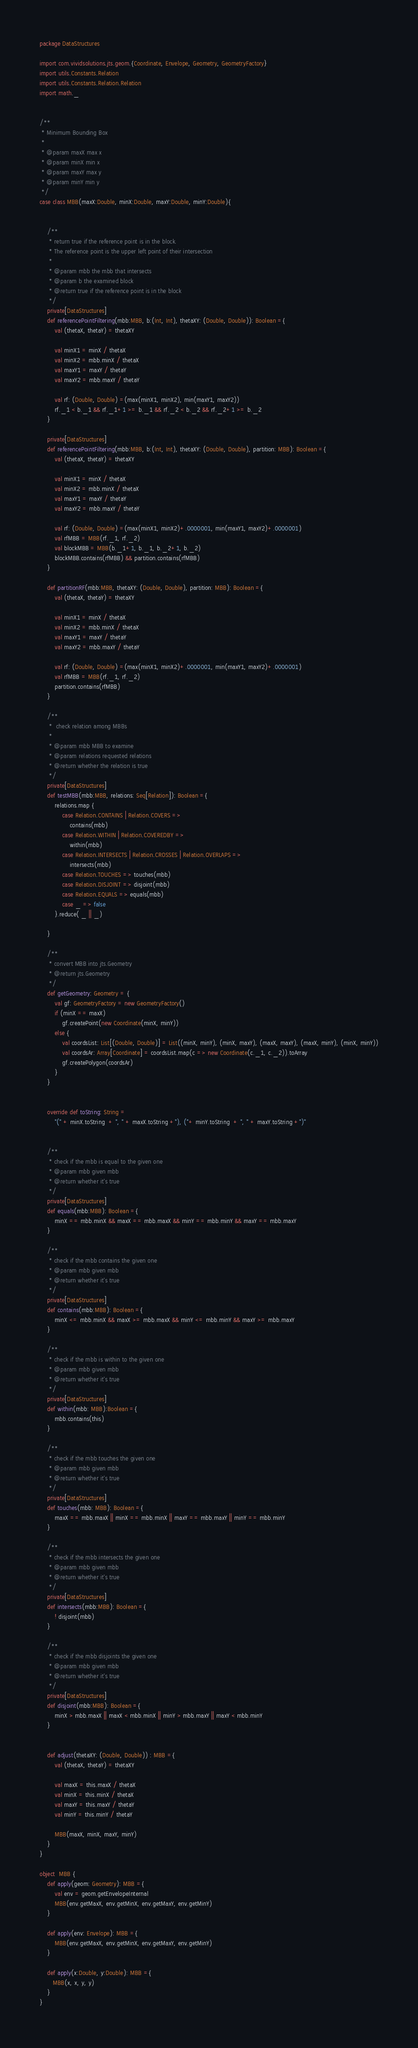Convert code to text. <code><loc_0><loc_0><loc_500><loc_500><_Scala_>package DataStructures

import com.vividsolutions.jts.geom.{Coordinate, Envelope, Geometry, GeometryFactory}
import utils.Constants.Relation
import utils.Constants.Relation.Relation
import math._


/**
 * Minimum Bounding Box
 *
 * @param maxX max x
 * @param minX min x
 * @param maxY max y
 * @param minY min y
 */
case class MBB(maxX:Double, minX:Double, maxY:Double, minY:Double){


    /**
     * return true if the reference point is in the block.
     * The reference point is the upper left point of their intersection
     *
     * @param mbb the mbb that intersects
     * @param b the examined block
     * @return true if the reference point is in the block
     */
    private[DataStructures]
    def referencePointFiltering(mbb:MBB, b:(Int, Int), thetaXY: (Double, Double)): Boolean ={
        val (thetaX, thetaY) = thetaXY

        val minX1 = minX / thetaX
        val minX2 = mbb.minX / thetaX
        val maxY1 = maxY / thetaY
        val maxY2 = mbb.maxY / thetaY

        val rf: (Double, Double) =(max(minX1, minX2), min(maxY1, maxY2))
        rf._1 < b._1 && rf._1+1 >= b._1 && rf._2 < b._2 && rf._2+1 >= b._2
    }

    private[DataStructures]
    def referencePointFiltering(mbb:MBB, b:(Int, Int), thetaXY: (Double, Double), partition: MBB): Boolean ={
        val (thetaX, thetaY) = thetaXY

        val minX1 = minX / thetaX
        val minX2 = mbb.minX / thetaX
        val maxY1 = maxY / thetaY
        val maxY2 = mbb.maxY / thetaY

        val rf: (Double, Double) =(max(minX1, minX2)+.0000001, min(maxY1, maxY2)+.0000001)
        val rfMBB = MBB(rf._1, rf._2)
        val blockMBB = MBB(b._1+1, b._1, b._2+1, b._2)
        blockMBB.contains(rfMBB) && partition.contains(rfMBB)
    }

    def partitionRF(mbb:MBB, thetaXY: (Double, Double), partition: MBB): Boolean ={
        val (thetaX, thetaY) = thetaXY

        val minX1 = minX / thetaX
        val minX2 = mbb.minX / thetaX
        val maxY1 = maxY / thetaY
        val maxY2 = mbb.maxY / thetaY

        val rf: (Double, Double) =(max(minX1, minX2)+.0000001, min(maxY1, maxY2)+.0000001)
        val rfMBB = MBB(rf._1, rf._2)
        partition.contains(rfMBB)
    }

    /**
     *  check relation among MBBs
     *
     * @param mbb MBB to examine
     * @param relations requested relations
     * @return whether the relation is true
     */
    private[DataStructures]
    def testMBB(mbb:MBB, relations: Seq[Relation]): Boolean ={
        relations.map {
            case Relation.CONTAINS | Relation.COVERS =>
                contains(mbb)
            case Relation.WITHIN | Relation.COVEREDBY =>
                within(mbb)
            case Relation.INTERSECTS | Relation.CROSSES | Relation.OVERLAPS =>
                intersects(mbb)
            case Relation.TOUCHES => touches(mbb)
            case Relation.DISJOINT => disjoint(mbb)
            case Relation.EQUALS => equals(mbb)
            case _ => false
        }.reduce( _ || _)

    }

    /**
     * convert MBB into jts.Geometry
     * @return jts.Geometry
     */
    def getGeometry: Geometry = {
        val gf: GeometryFactory = new GeometryFactory()
        if (minX == maxX)
            gf.createPoint(new Coordinate(minX, minY))
        else {
            val coordsList: List[(Double, Double)] = List((minX, minY), (minX, maxY), (maxX, maxY), (maxX, minY), (minX, minY))
            val coordsAr: Array[Coordinate] = coordsList.map(c => new Coordinate(c._1, c._2)).toArray
            gf.createPolygon(coordsAr)
        }
    }


    override def toString: String =
        "(" + minX.toString  + ", " + maxX.toString +"), ("+ minY.toString  + ", " + maxY.toString +")"


    /**
     * check if the mbb is equal to the given one
     * @param mbb given mbb
     * @return whether it's true
     */
    private[DataStructures]
    def equals(mbb:MBB): Boolean ={
        minX == mbb.minX && maxX == mbb.maxX && minY == mbb.minY && maxY == mbb.maxY
    }

    /**
     * check if the mbb contains the given one
     * @param mbb given mbb
     * @return whether it's true
     */
    private[DataStructures]
    def contains(mbb:MBB): Boolean ={
        minX <= mbb.minX && maxX >= mbb.maxX && minY <= mbb.minY && maxY >= mbb.maxY
    }

    /**
     * check if the mbb is within to the given one
     * @param mbb given mbb
     * @return whether it's true
     */
    private[DataStructures]
    def within(mbb: MBB):Boolean ={
        mbb.contains(this)
    }

    /**
     * check if the mbb touches the given one
     * @param mbb given mbb
     * @return whether it's true
     */
    private[DataStructures]
    def touches(mbb: MBB): Boolean ={
        maxX == mbb.maxX || minX == mbb.minX || maxY == mbb.maxY || minY == mbb.minY
    }

    /**
     * check if the mbb intersects the given one
     * @param mbb given mbb
     * @return whether it's true
     */
    private[DataStructures]
    def intersects(mbb:MBB): Boolean ={
        ! disjoint(mbb)
    }

    /**
     * check if the mbb disjoints the given one
     * @param mbb given mbb
     * @return whether it's true
     */
    private[DataStructures]
    def disjoint(mbb:MBB): Boolean ={
        minX > mbb.maxX || maxX < mbb.minX || minY > mbb.maxY || maxY < mbb.minY
    }


    def adjust(thetaXY: (Double, Double)) : MBB ={
        val (thetaX, thetaY) = thetaXY

        val maxX = this.maxX / thetaX
        val minX = this.minX / thetaX
        val maxY = this.maxY / thetaY
        val minY = this.minY / thetaY

        MBB(maxX, minX, maxY, minY)
    }
}

object  MBB {
    def apply(geom: Geometry): MBB ={
        val env = geom.getEnvelopeInternal
        MBB(env.getMaxX, env.getMinX, env.getMaxY, env.getMinY)
    }

    def apply(env: Envelope): MBB ={
        MBB(env.getMaxX, env.getMinX, env.getMaxY, env.getMinY)
    }

    def apply(x:Double, y:Double): MBB ={
       MBB(x, x, y, y)
    }
}
</code> 